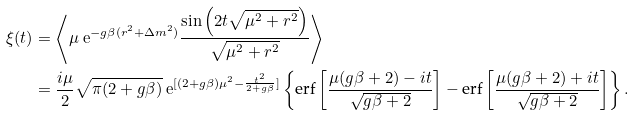Convert formula to latex. <formula><loc_0><loc_0><loc_500><loc_500>\xi ( t ) & = \left \langle \mu \ \mathrm e ^ { - g \beta ( r ^ { 2 } + \Delta m ^ { 2 } ) } \frac { \sin \left ( 2 t \sqrt { \mu ^ { 2 } + r ^ { 2 } } \right ) } { \sqrt { \mu ^ { 2 } + r ^ { 2 } } } \right \rangle \\ & = \frac { i \mu } { 2 } \sqrt { \pi ( 2 + g \beta ) } \ \mathrm e ^ { [ ( 2 + g \beta ) \mu ^ { 2 } - \frac { t ^ { 2 } } { 2 + g \beta } ] } \left \{ \text {erf} \left [ \frac { \mu ( g \beta + 2 ) - i t } { \sqrt { g \beta + 2 } } \right ] - \text {erf} \left [ \frac { \mu ( g \beta + 2 ) + i t } { \sqrt { g \beta + 2 } } \right ] \right \} .</formula> 